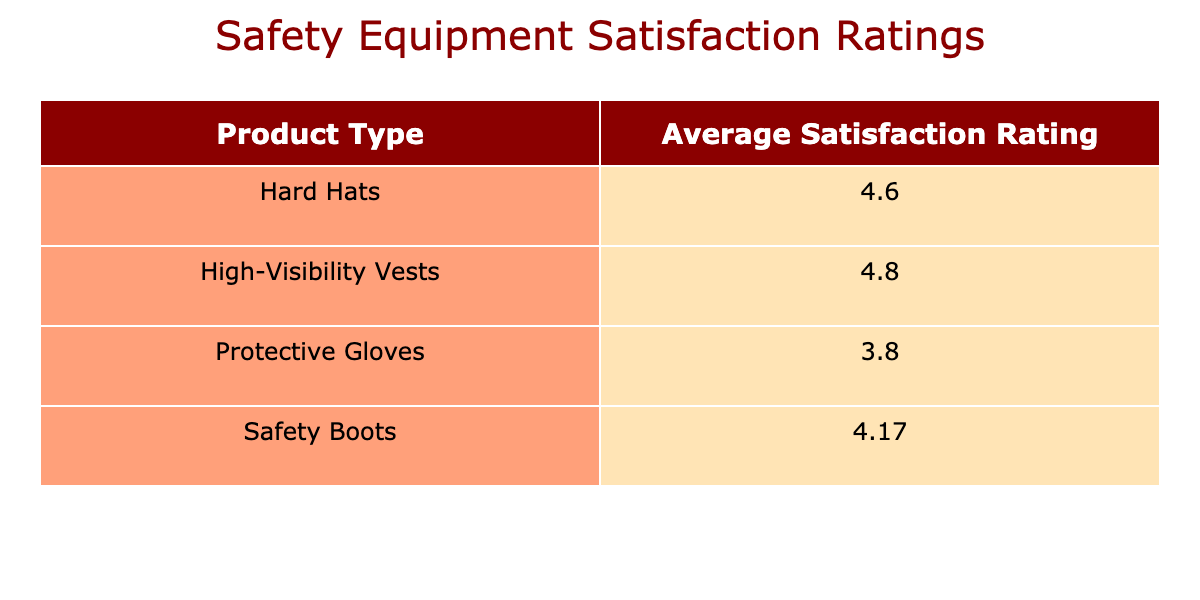What is the average satisfaction rating for Hard Hats? To find the average satisfaction rating for Hard Hats, we look at the satisfaction ratings in the table for Hard Hats: 4.5 (Q1 2023), 4.7 (Q2 2023), and 4.6 (Q4 2023). We sum these values: 4.5 + 4.7 + 4.6 = 13.8. There are 3 ratings, so the average is 13.8 / 3 = 4.6.
Answer: 4.6 Which product type received the highest average satisfaction rating? We can compare the average satisfaction ratings for each product type listed in the table. The ratings are: Hard Hats (4.6), Protective Gloves (3.8), and Safety Boots (4.2). Among these, Hard Hats have the highest satisfaction rating of 4.6.
Answer: Hard Hats Did any customer report a satisfaction rating below 4 for any product type? Looking at the satisfaction ratings provided in the table, the only rating below 4 is for SecureCo's Protective Gloves in Q3 2023, which is 3.5. So yes, there is a product type with a rating below 4.
Answer: Yes What is the average satisfaction rating for Protective Gloves? We'll check the satisfaction ratings for Protective Gloves: 3.8 (Q1 2023), 4.1 (Q2 2023), and 3.5 (Q3 2023). Adding them gives us: 3.8 + 4.1 + 3.5 = 11.4. There are 3 ratings, resulting in an average of 11.4 / 3 = 3.8.
Answer: 3.8 Is the average satisfaction rating for Safety Boots higher than that of Protective Gloves? The average satisfaction ratings for Safety Boots is 4.2, while for Protective Gloves it is 3.8. Since 4.2 is greater than 3.8, we can conclude that the average rating for Safety Boots is indeed higher.
Answer: Yes What is the total number of customer responses for each product type? The total number of responses for each product type is calculated by counting the entries in the table for each. For Hard Hats, there are 3 responses; for Protective Gloves, there are also 3 responses; and for Safety Boots, there are 3 as well. This gives us totals of 3 responses for each product type.
Answer: 3 for each product type What is the difference in average satisfaction ratings between Safety Boots and Protective Gloves? The average for Safety Boots is 4.2 and for Protective Gloves, it is 3.8. The difference is calculated as 4.2 - 3.8 = 0.4, indicating that Safety Boots have a higher average rating by this amount.
Answer: 0.4 Which quarter showed the highest satisfaction rating for Safety Boots? From the table, the satisfaction ratings for Safety Boots across quarters are: 4.2 (Q1 2023), 4.0 (Q2 2023), and 4.3 (Q3 2023). The highest rating among these is 4.3 in Q3 2023.
Answer: Q3 2023 